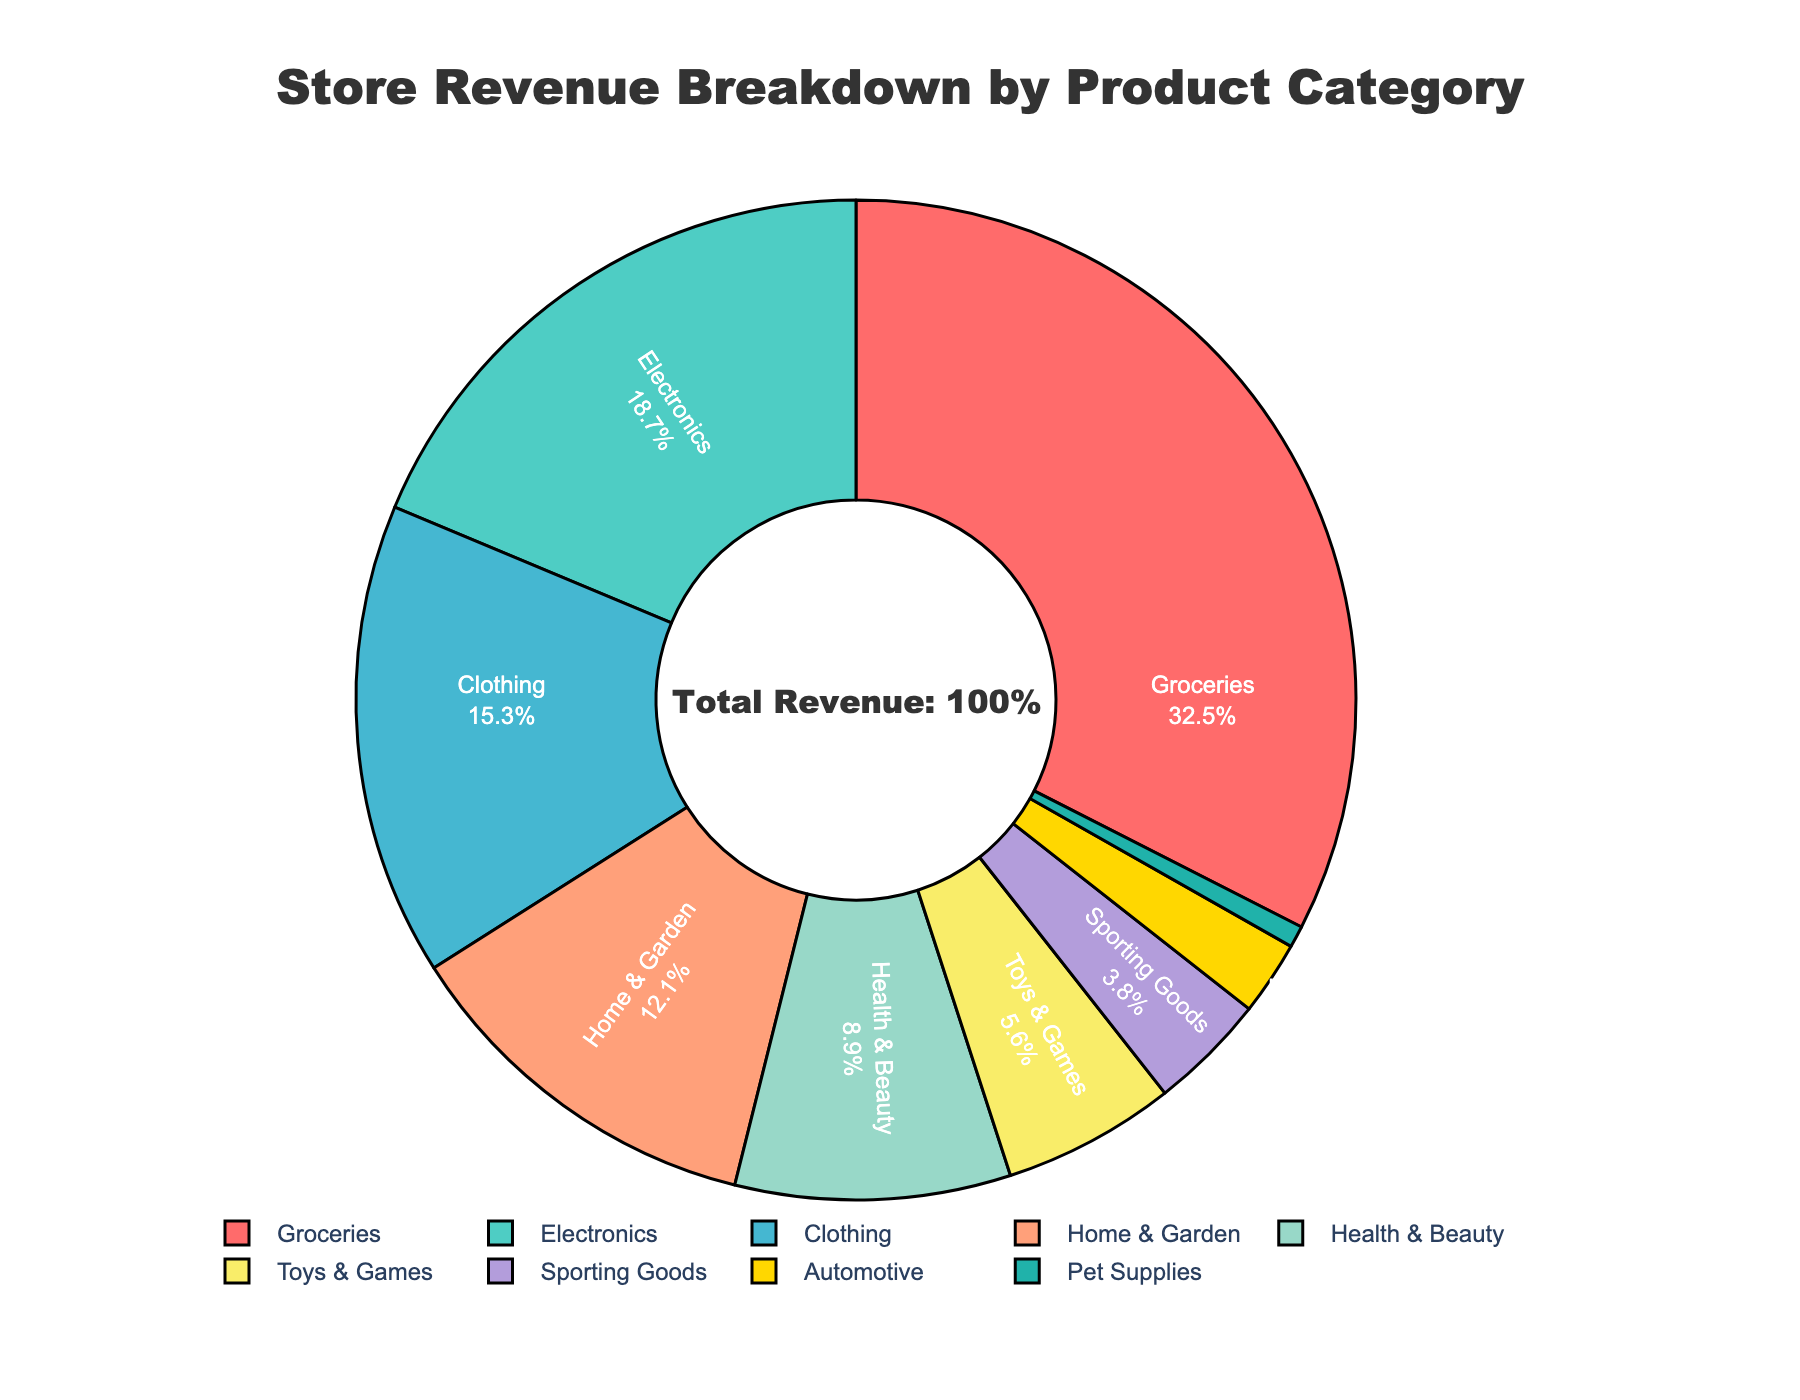What is the product category with the highest revenue percentage? The product category with the highest revenue percentage is the one occupying the largest section of the pie chart. In this case, it is "Groceries" at 32.5%.
Answer: Groceries Which product category has the lowest revenue percentage? The product category with the lowest revenue percentage is the smallest section of the pie chart. It is "Pet Supplies" at 0.7%.
Answer: Pet Supplies What is the combined revenue percentage for Electronics and Clothing? To find the combined revenue percentage, add the individual percentages for Electronics (18.7%) and Clothing (15.3%). The calculation is 18.7% + 15.3% = 34%.
Answer: 34% How does the revenue from Health & Beauty compare to Sporting Goods? Compare the revenue percentages of Health & Beauty (8.9%) and Sporting Goods (3.8%). Health & Beauty has a higher revenue percentage than Sporting Goods.
Answer: Health & Beauty has a higher revenue Which product categories combined make up more than 50% of the total revenue? Identify all product categories whose cumulative percentage exceeds 50%. Groceries (32.5%) + Electronics (18.7%) = 51.2%, which is more than 50%.
Answer: Groceries and Electronics What percentage of revenue comes from categories other than Groceries and Electronics? Subtract the combined percentage of Groceries and Electronics from 100%. The calculation is 100% - (32.5% + 18.7%) = 48.8%.
Answer: 48.8% How much more revenue percentage does Groceries generate compared to Home & Garden? Subtract Home & Garden's percentage (12.1%) from Groceries' percentage (32.5%). The calculation is 32.5% - 12.1% = 20.4%.
Answer: 20.4% What is the average revenue percentage of Health & Beauty, Toys & Games, and Sporting Goods? To find the average revenue percentage, add the percentages of Health & Beauty (8.9%), Toys & Games (5.6%), and Sporting Goods (3.8%) and divide by 3. The calculation is (8.9% + 5.6% + 3.8%) / 3 ≈ 6.1%.
Answer: 6.1% If the revenue percentage of Automotive doubled, what would it be, and how would it rank among the other categories? Double the current revenue percentage of Automotive (2.4%) to get 4.8%. Compare this with the other percentages to determine its rank. Automotive at 4.8% would rank between Toys & Games (5.6%) and Sporting Goods (3.8%).
Answer: 4.8% and rank between Toys & Games and Sporting Goods What proportion of the pie chart do Groceries, Electronics, and Clothing together occupy in terms of percentage? Add the percentages for Groceries (32.5%), Electronics (18.7%), and Clothing (15.3%). The calculation is 32.5% + 18.7% + 15.3% = 66.5%.
Answer: 66.5% 